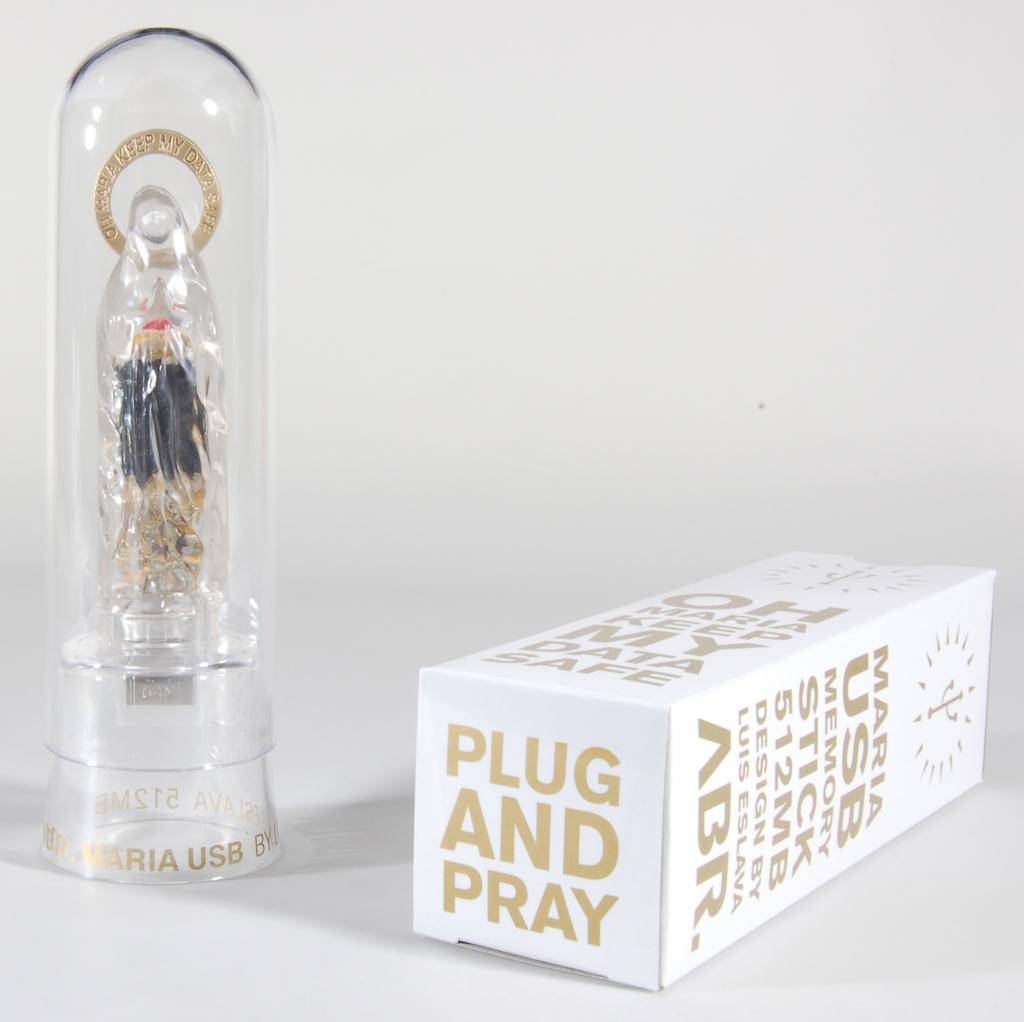<image>
Render a clear and concise summary of the photo. a white box with gold lettering that says 'plug and pray' 